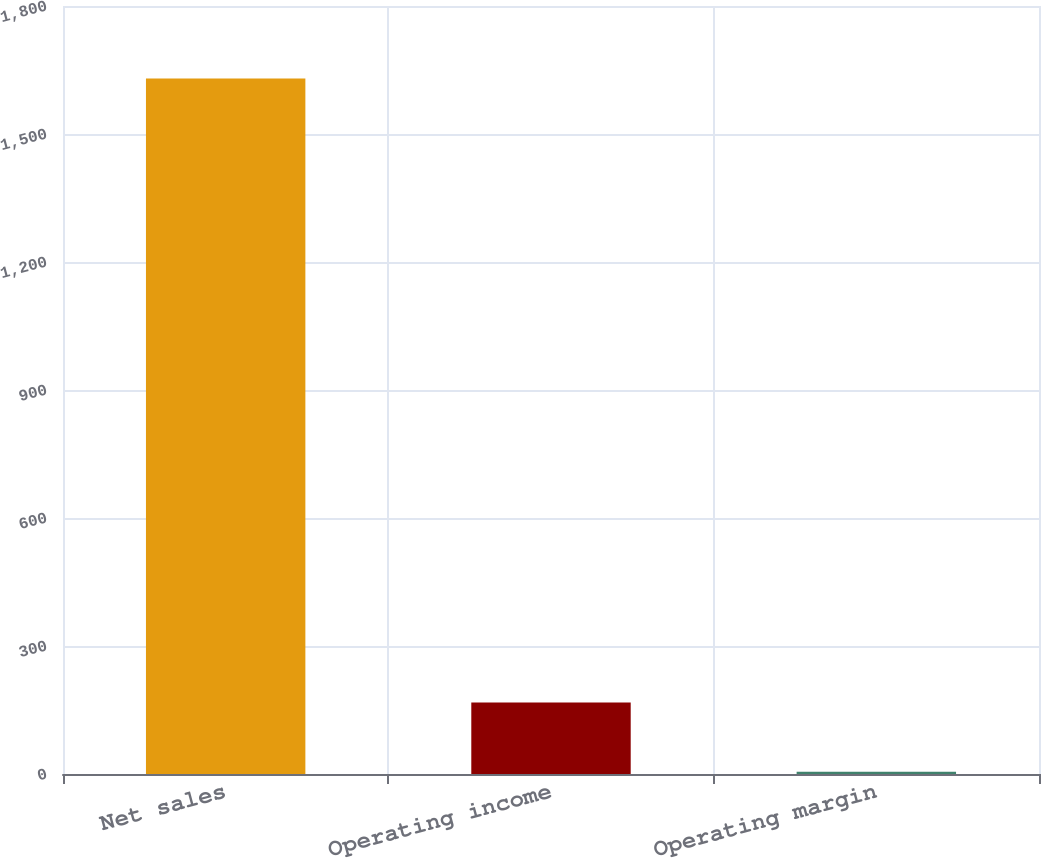Convert chart to OTSL. <chart><loc_0><loc_0><loc_500><loc_500><bar_chart><fcel>Net sales<fcel>Operating income<fcel>Operating margin<nl><fcel>1630<fcel>167.77<fcel>5.3<nl></chart> 